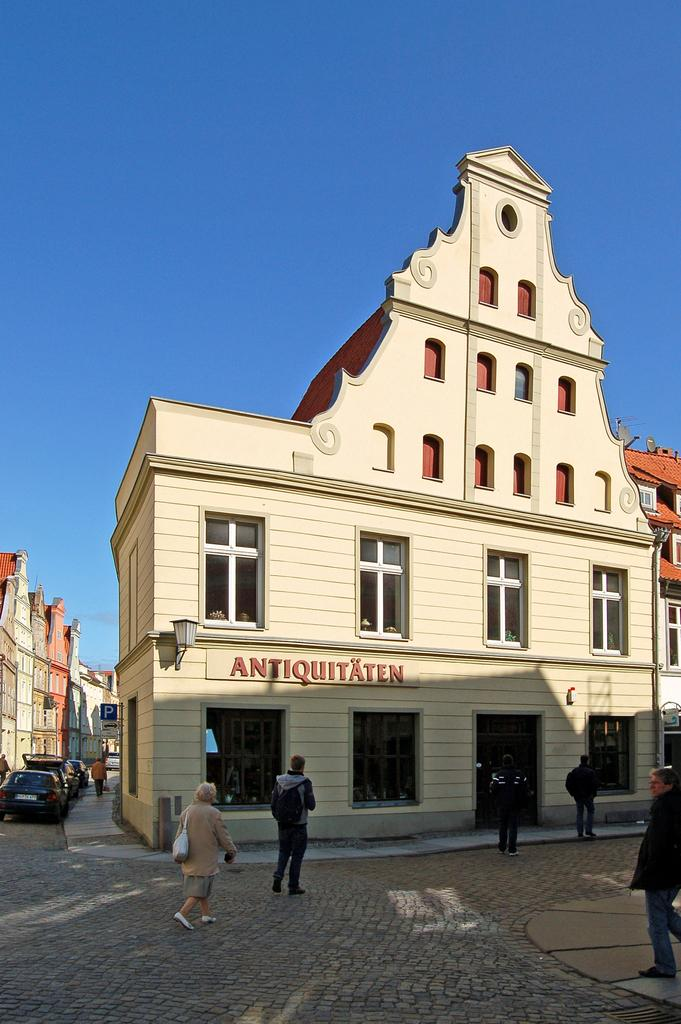Provide a one-sentence caption for the provided image. German market street with a shop that reads ANTIQUITAEN. 